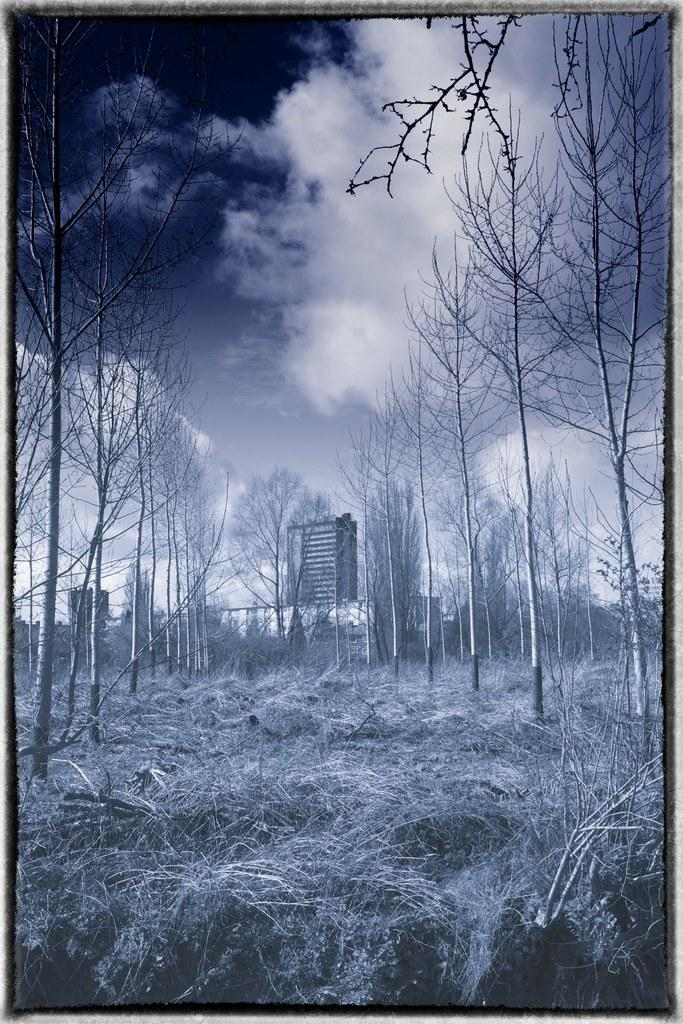What type of vegetation is present at the bottom of the image? There is grass on the ground at the bottom of the image. What can be seen on the sides of the image? There are bare trees on the left and right sides of the image. What is visible in the background of the image? There are trees, a hoarding, and an object in the background of the image. Additionally, there are clouds in the sky in the background of the image. What type of sack is being used by the cook in the image? There is no cook or sack present in the image. How many trains can be seen in the image? There are no trains visible in the image. 